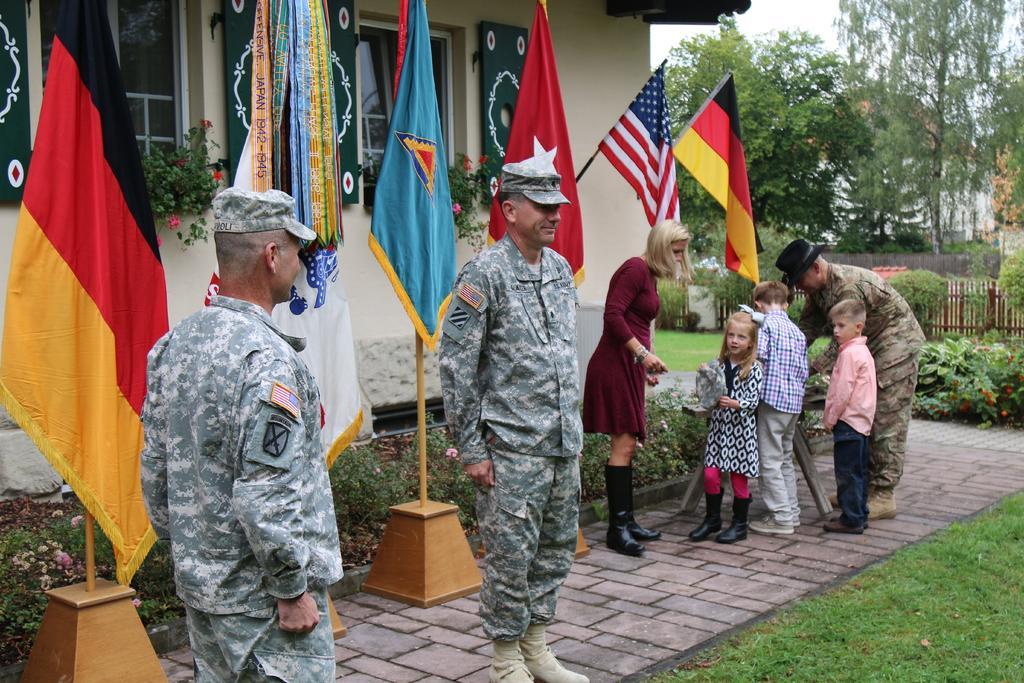Can you describe this image briefly? On the right side of the image we can see persons standing on the floor and trees, fencing and wall. On the left side of the image we can see flag, person and plants. In the center of the image there is a person standing on the floor. In the background there are flags, building, trees and sky. 